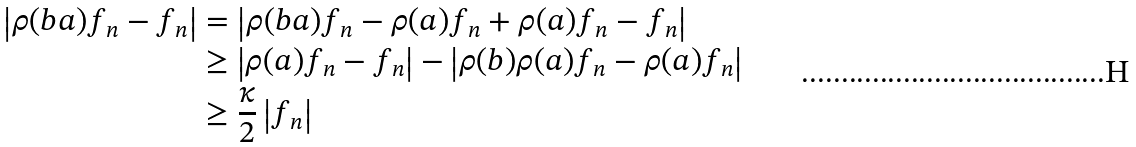Convert formula to latex. <formula><loc_0><loc_0><loc_500><loc_500>\left | \rho ( b a ) f _ { n } - f _ { n } \right | & = \left | \rho ( b a ) f _ { n } - \rho ( a ) f _ { n } + \rho ( a ) f _ { n } - f _ { n } \right | \\ & \geq \left | \rho ( a ) f _ { n } - f _ { n } \right | - \left | \rho ( b ) \rho ( a ) f _ { n } - \rho ( a ) f _ { n } \right | \\ & \geq \frac { \kappa } { 2 } \left | f _ { n } \right |</formula> 